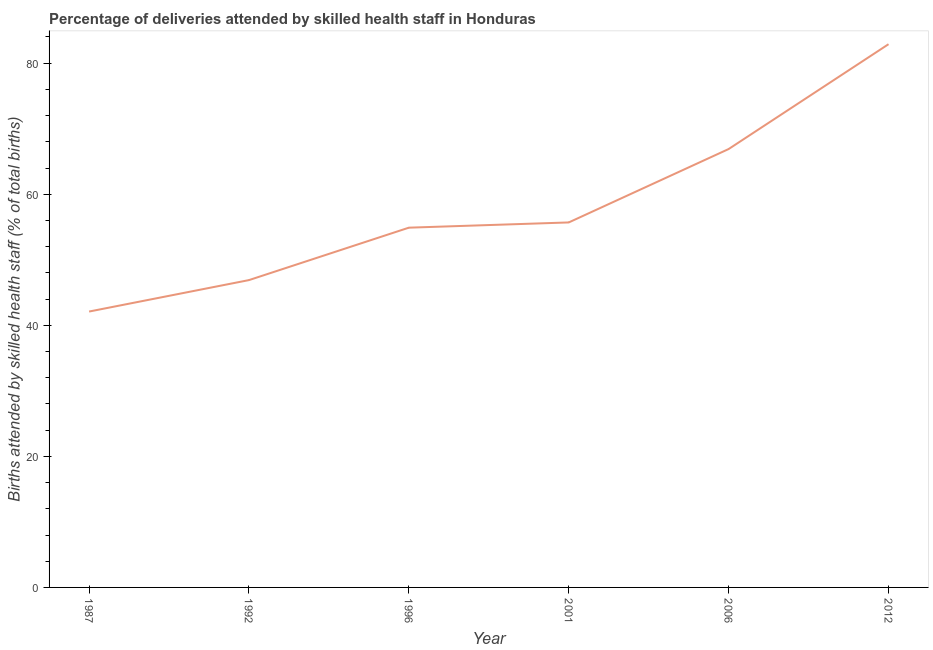What is the number of births attended by skilled health staff in 2012?
Provide a short and direct response. 82.9. Across all years, what is the maximum number of births attended by skilled health staff?
Offer a very short reply. 82.9. Across all years, what is the minimum number of births attended by skilled health staff?
Make the answer very short. 42.1. What is the sum of the number of births attended by skilled health staff?
Give a very brief answer. 349.4. What is the difference between the number of births attended by skilled health staff in 1992 and 2012?
Provide a succinct answer. -36. What is the average number of births attended by skilled health staff per year?
Ensure brevity in your answer.  58.23. What is the median number of births attended by skilled health staff?
Keep it short and to the point. 55.3. In how many years, is the number of births attended by skilled health staff greater than 64 %?
Keep it short and to the point. 2. What is the ratio of the number of births attended by skilled health staff in 1987 to that in 2012?
Your answer should be very brief. 0.51. What is the difference between the highest and the second highest number of births attended by skilled health staff?
Offer a very short reply. 16. Is the sum of the number of births attended by skilled health staff in 1987 and 2001 greater than the maximum number of births attended by skilled health staff across all years?
Your answer should be compact. Yes. What is the difference between the highest and the lowest number of births attended by skilled health staff?
Provide a succinct answer. 40.8. How many lines are there?
Provide a succinct answer. 1. How many years are there in the graph?
Offer a very short reply. 6. What is the difference between two consecutive major ticks on the Y-axis?
Your answer should be compact. 20. Does the graph contain any zero values?
Offer a terse response. No. Does the graph contain grids?
Keep it short and to the point. No. What is the title of the graph?
Ensure brevity in your answer.  Percentage of deliveries attended by skilled health staff in Honduras. What is the label or title of the Y-axis?
Ensure brevity in your answer.  Births attended by skilled health staff (% of total births). What is the Births attended by skilled health staff (% of total births) in 1987?
Ensure brevity in your answer.  42.1. What is the Births attended by skilled health staff (% of total births) of 1992?
Give a very brief answer. 46.9. What is the Births attended by skilled health staff (% of total births) of 1996?
Provide a short and direct response. 54.9. What is the Births attended by skilled health staff (% of total births) of 2001?
Your response must be concise. 55.7. What is the Births attended by skilled health staff (% of total births) of 2006?
Offer a terse response. 66.9. What is the Births attended by skilled health staff (% of total births) of 2012?
Offer a terse response. 82.9. What is the difference between the Births attended by skilled health staff (% of total births) in 1987 and 2006?
Your response must be concise. -24.8. What is the difference between the Births attended by skilled health staff (% of total births) in 1987 and 2012?
Provide a short and direct response. -40.8. What is the difference between the Births attended by skilled health staff (% of total births) in 1992 and 1996?
Your answer should be compact. -8. What is the difference between the Births attended by skilled health staff (% of total births) in 1992 and 2012?
Your answer should be compact. -36. What is the difference between the Births attended by skilled health staff (% of total births) in 1996 and 2012?
Ensure brevity in your answer.  -28. What is the difference between the Births attended by skilled health staff (% of total births) in 2001 and 2006?
Keep it short and to the point. -11.2. What is the difference between the Births attended by skilled health staff (% of total births) in 2001 and 2012?
Keep it short and to the point. -27.2. What is the difference between the Births attended by skilled health staff (% of total births) in 2006 and 2012?
Your response must be concise. -16. What is the ratio of the Births attended by skilled health staff (% of total births) in 1987 to that in 1992?
Offer a very short reply. 0.9. What is the ratio of the Births attended by skilled health staff (% of total births) in 1987 to that in 1996?
Keep it short and to the point. 0.77. What is the ratio of the Births attended by skilled health staff (% of total births) in 1987 to that in 2001?
Your answer should be compact. 0.76. What is the ratio of the Births attended by skilled health staff (% of total births) in 1987 to that in 2006?
Give a very brief answer. 0.63. What is the ratio of the Births attended by skilled health staff (% of total births) in 1987 to that in 2012?
Your response must be concise. 0.51. What is the ratio of the Births attended by skilled health staff (% of total births) in 1992 to that in 1996?
Your answer should be very brief. 0.85. What is the ratio of the Births attended by skilled health staff (% of total births) in 1992 to that in 2001?
Provide a short and direct response. 0.84. What is the ratio of the Births attended by skilled health staff (% of total births) in 1992 to that in 2006?
Your response must be concise. 0.7. What is the ratio of the Births attended by skilled health staff (% of total births) in 1992 to that in 2012?
Offer a very short reply. 0.57. What is the ratio of the Births attended by skilled health staff (% of total births) in 1996 to that in 2006?
Make the answer very short. 0.82. What is the ratio of the Births attended by skilled health staff (% of total births) in 1996 to that in 2012?
Your response must be concise. 0.66. What is the ratio of the Births attended by skilled health staff (% of total births) in 2001 to that in 2006?
Your answer should be compact. 0.83. What is the ratio of the Births attended by skilled health staff (% of total births) in 2001 to that in 2012?
Give a very brief answer. 0.67. What is the ratio of the Births attended by skilled health staff (% of total births) in 2006 to that in 2012?
Give a very brief answer. 0.81. 